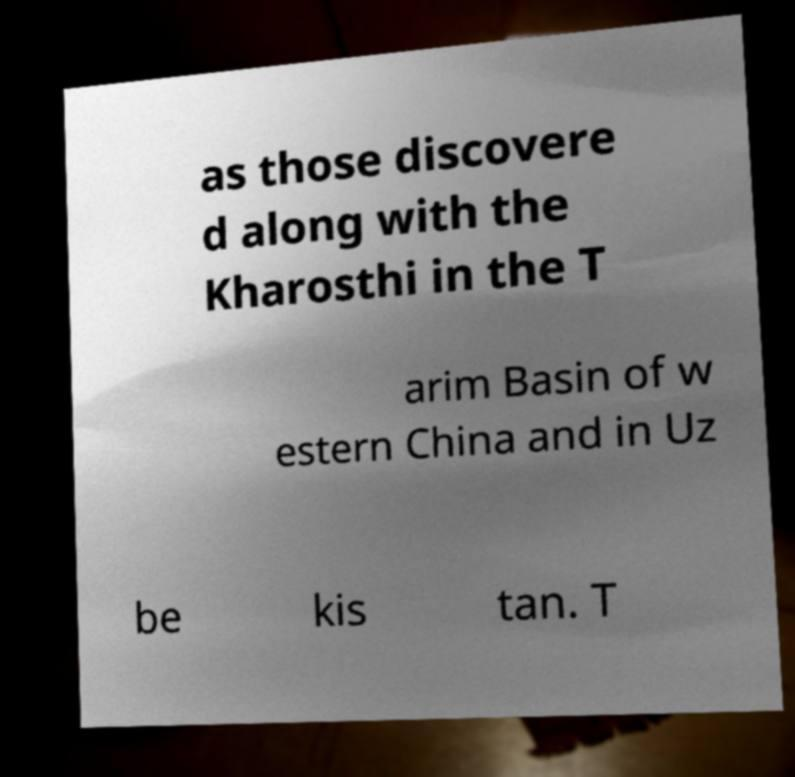Could you extract and type out the text from this image? as those discovere d along with the Kharosthi in the T arim Basin of w estern China and in Uz be kis tan. T 